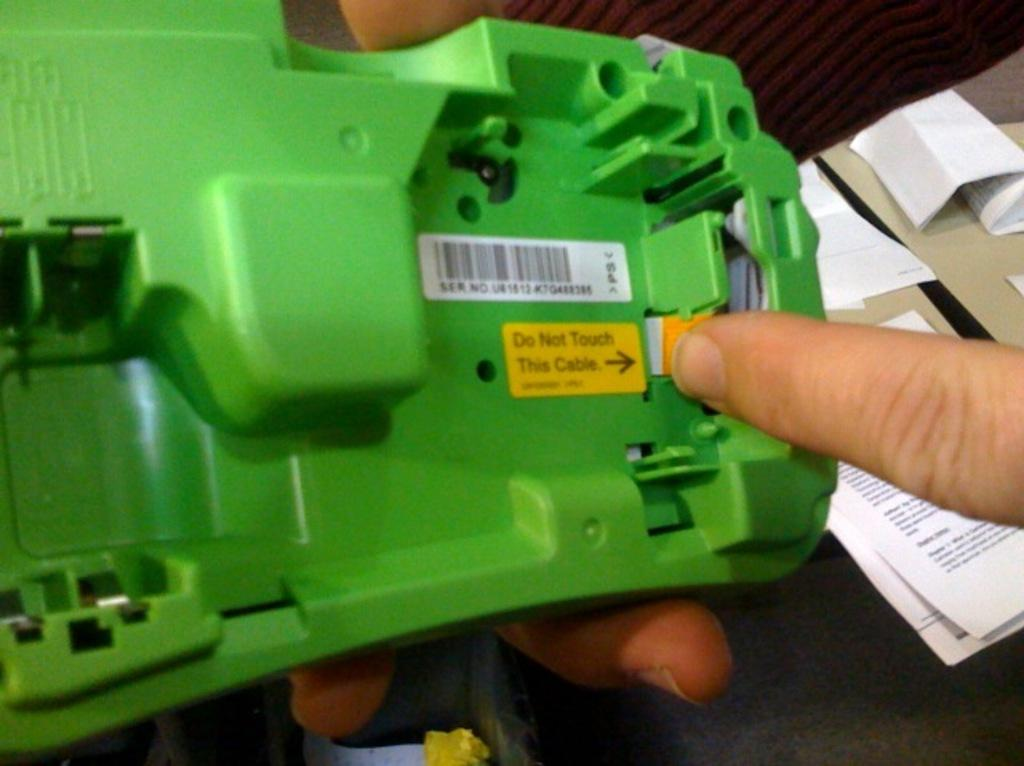Who or what is present in the image? There is a person in the image. What is the person doing in the image? The person is holding an object. What can be seen on the right side of the image? There are papers on the right side of the image. What is the person's desire for prison reform in the image? There is no mention of prison or prison reform in the image, so it is not possible to answer that question. 